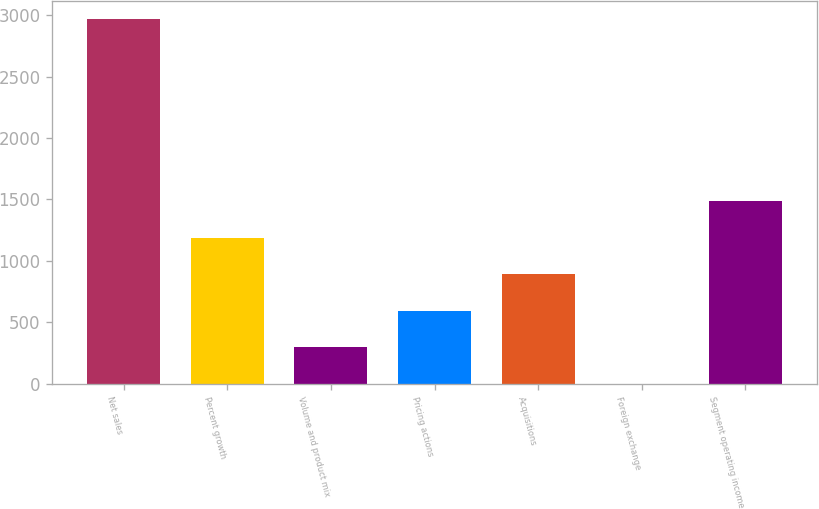Convert chart to OTSL. <chart><loc_0><loc_0><loc_500><loc_500><bar_chart><fcel>Net sales<fcel>Percent growth<fcel>Volume and product mix<fcel>Pricing actions<fcel>Acquisitions<fcel>Foreign exchange<fcel>Segment operating income<nl><fcel>2970.1<fcel>1188.1<fcel>297.1<fcel>594.1<fcel>891.1<fcel>0.1<fcel>1485.1<nl></chart> 